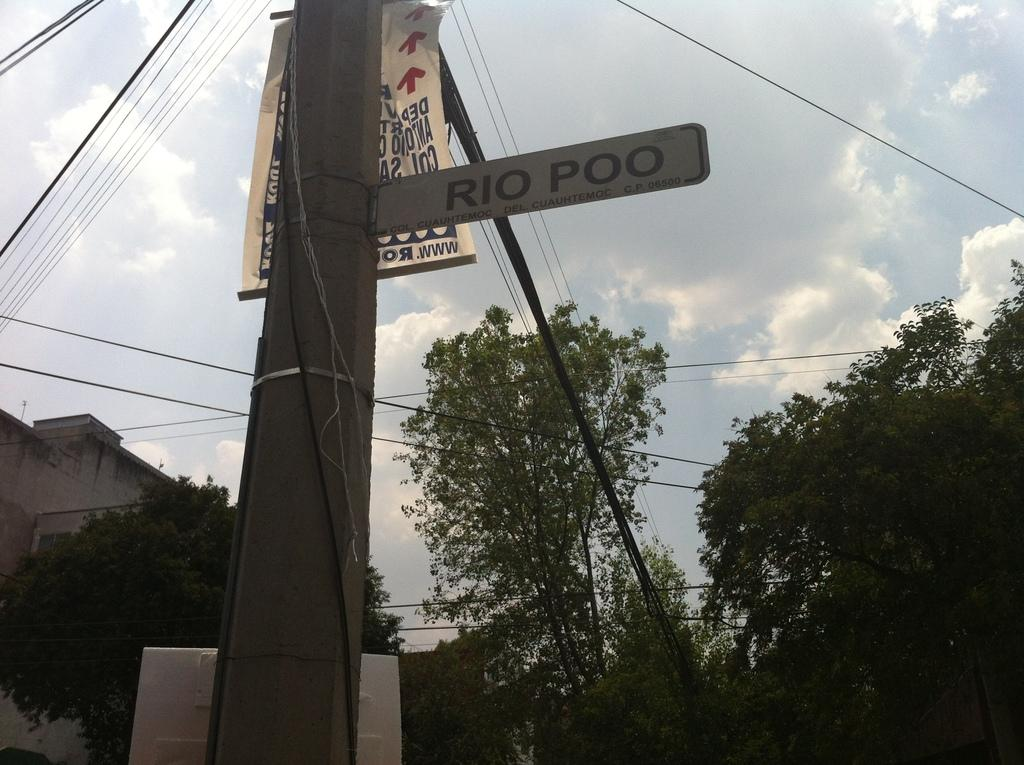What is the main structure in the image? There is a pole in the image. What is connected to the pole? Wires are attached to the pole. What else can be seen near the pole? There are boards and a banner near the pole. What can be seen in the background of the image? Trees, a building, and the sky are visible in the background of the image. How does the kettle twist around the pole in the image? There is no kettle present in the image, so it cannot twist around the pole. 